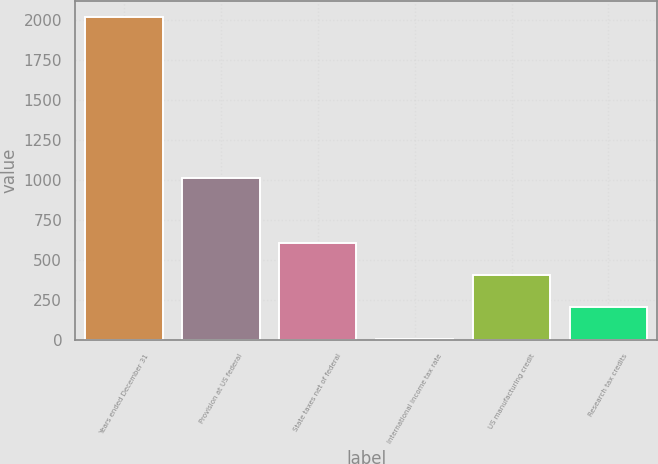<chart> <loc_0><loc_0><loc_500><loc_500><bar_chart><fcel>Years ended December 31<fcel>Provision at US federal<fcel>State taxes net of federal<fcel>International income tax rate<fcel>US manufacturing credit<fcel>Research tax credits<nl><fcel>2015<fcel>1007.6<fcel>604.64<fcel>0.2<fcel>403.16<fcel>201.68<nl></chart> 